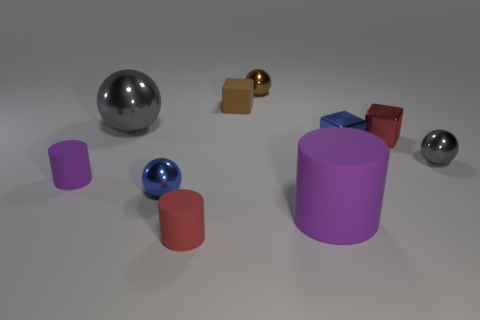How many objects are there in the image, and can you classify them by shape? There are eight objects in the image. They can be classified by shape as follows: three spheres, two cylinders, and three cubes. 